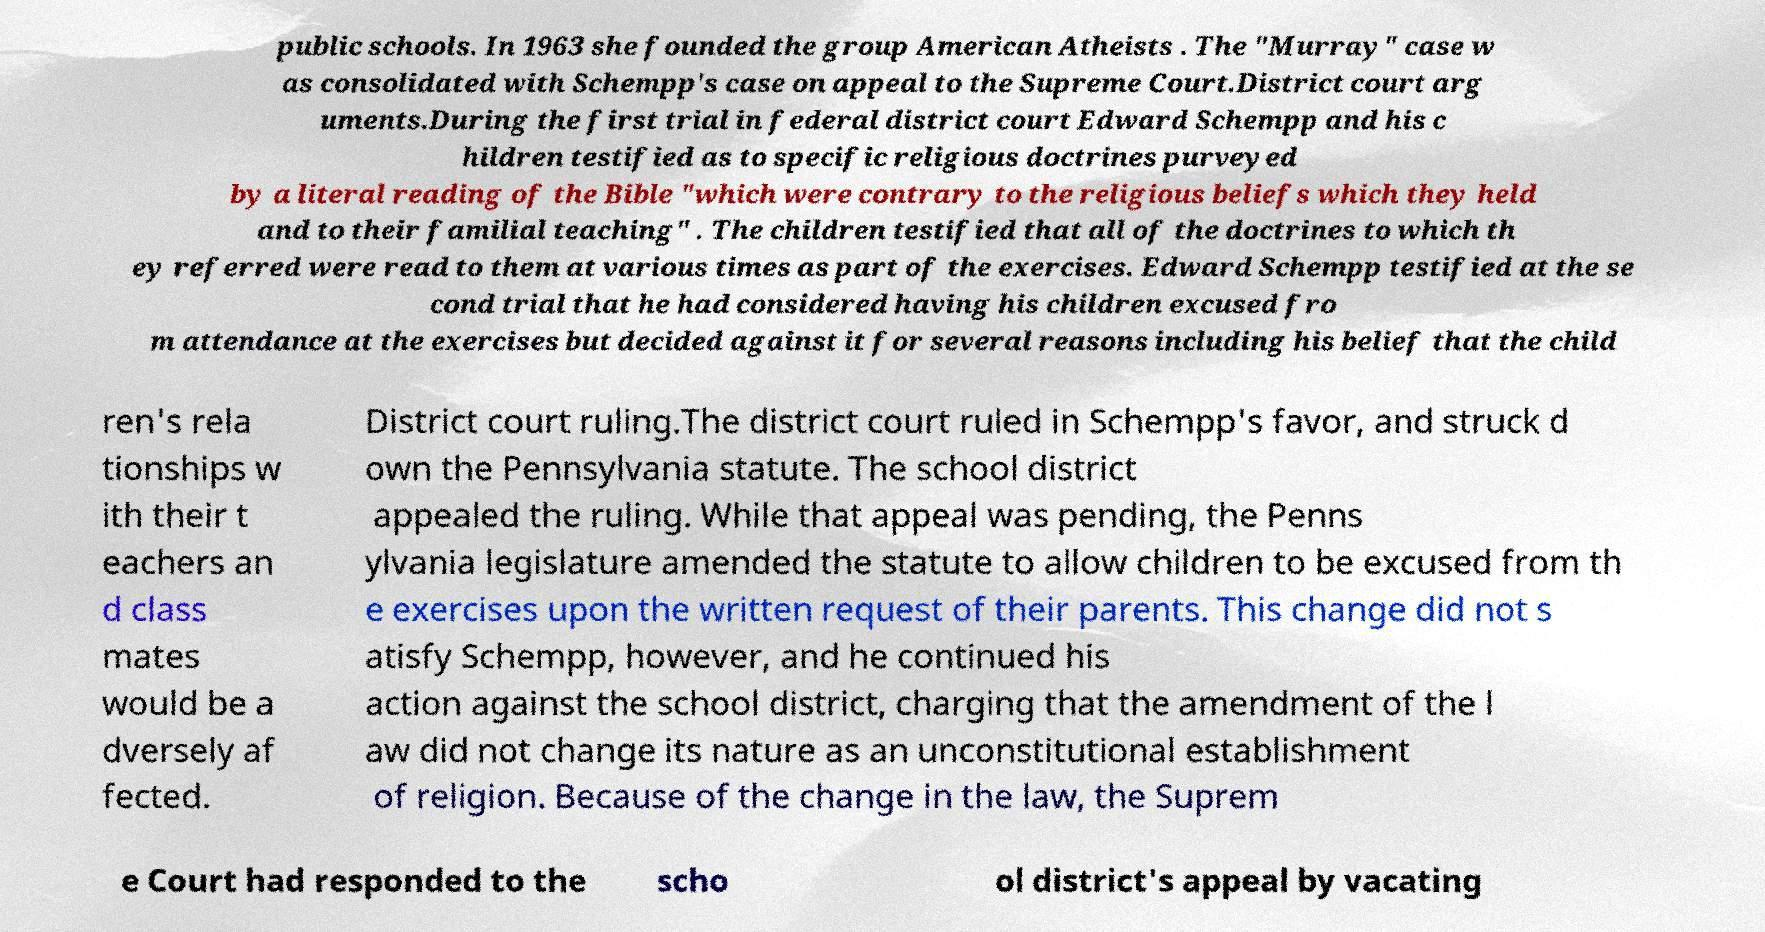Could you assist in decoding the text presented in this image and type it out clearly? public schools. In 1963 she founded the group American Atheists . The "Murray" case w as consolidated with Schempp's case on appeal to the Supreme Court.District court arg uments.During the first trial in federal district court Edward Schempp and his c hildren testified as to specific religious doctrines purveyed by a literal reading of the Bible "which were contrary to the religious beliefs which they held and to their familial teaching" . The children testified that all of the doctrines to which th ey referred were read to them at various times as part of the exercises. Edward Schempp testified at the se cond trial that he had considered having his children excused fro m attendance at the exercises but decided against it for several reasons including his belief that the child ren's rela tionships w ith their t eachers an d class mates would be a dversely af fected. District court ruling.The district court ruled in Schempp's favor, and struck d own the Pennsylvania statute. The school district appealed the ruling. While that appeal was pending, the Penns ylvania legislature amended the statute to allow children to be excused from th e exercises upon the written request of their parents. This change did not s atisfy Schempp, however, and he continued his action against the school district, charging that the amendment of the l aw did not change its nature as an unconstitutional establishment of religion. Because of the change in the law, the Suprem e Court had responded to the scho ol district's appeal by vacating 